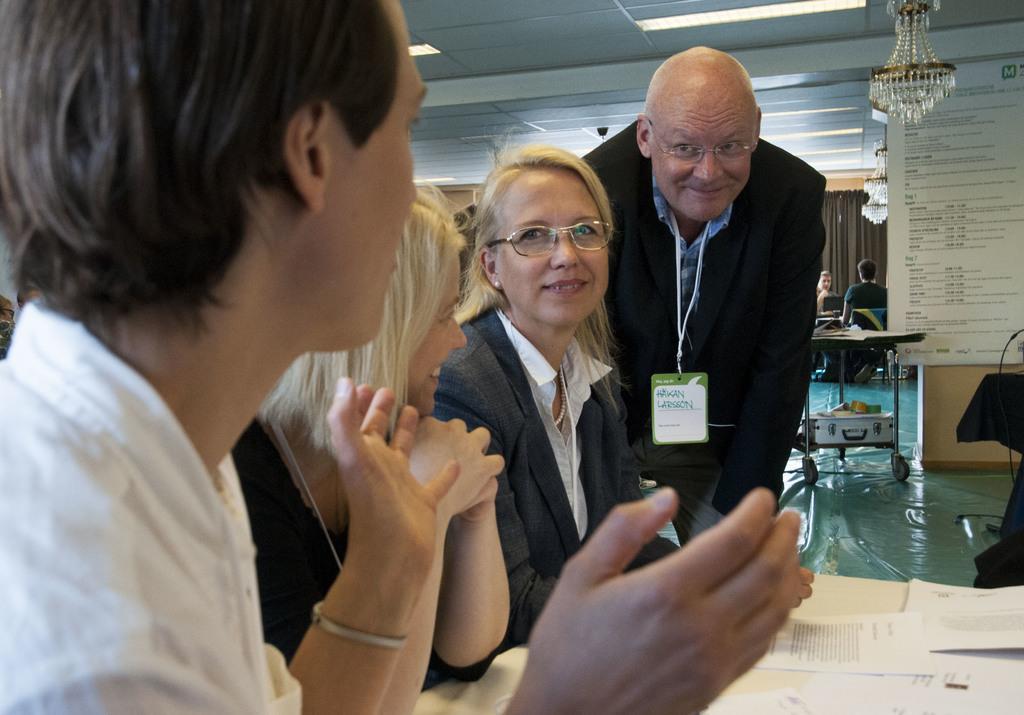Please provide a concise description of this image. In this image we can see a group of persons are sitting and smiling, at beside here a man is standing, he is wearing the suit, in front here is the table and papers on it, here is the chandelier, here is the light, here is the roof. 